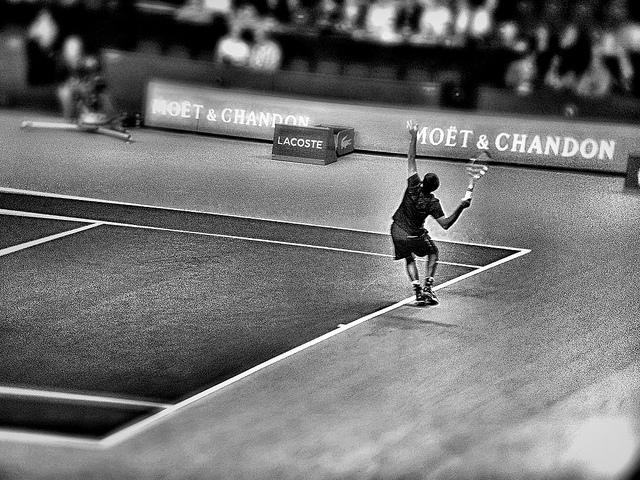Who might be a sponsor of this arena?
Write a very short answer. Moet & chandon. What sport is this?
Answer briefly. Tennis. Is this event being televised?
Answer briefly. Yes. 